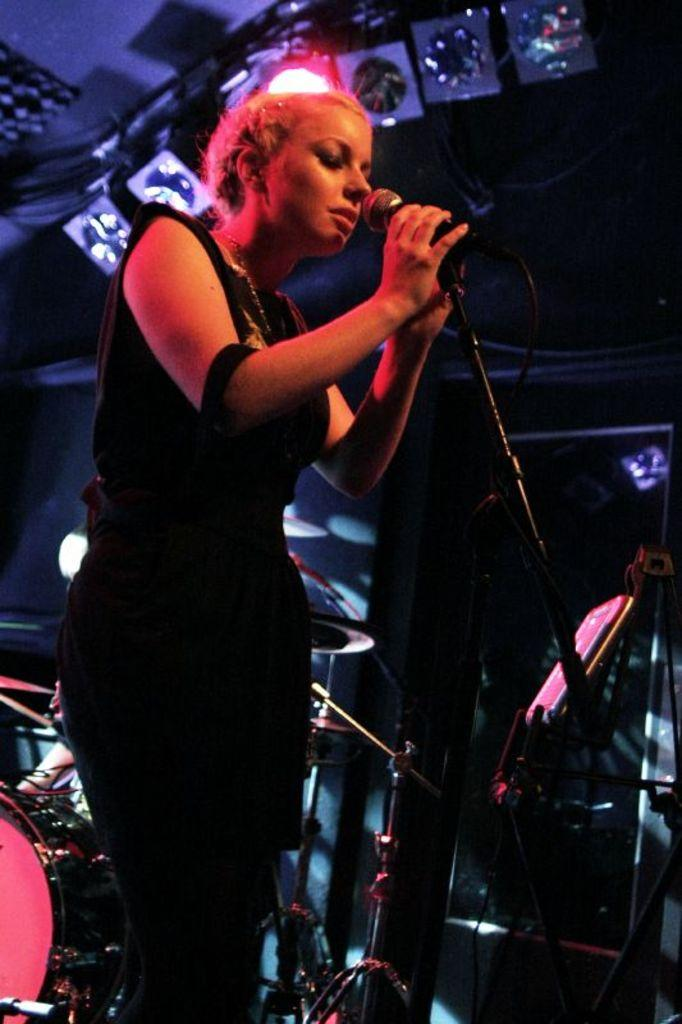Who is the main subject in the image? There is a woman in the image. What is the woman doing in the image? The woman is standing in front of a microphone. What else can be seen in the image besides the woman? There are musical instruments in the middle of the image. What type of creature can be seen playing with a crayon in the image? There is no creature, let alone one playing with a crayon, in the image. 